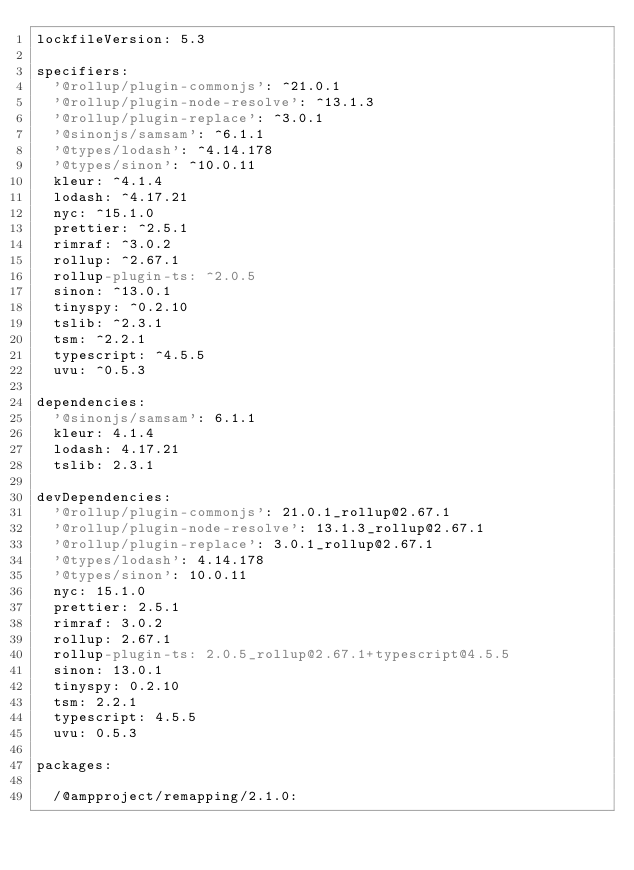<code> <loc_0><loc_0><loc_500><loc_500><_YAML_>lockfileVersion: 5.3

specifiers:
  '@rollup/plugin-commonjs': ^21.0.1
  '@rollup/plugin-node-resolve': ^13.1.3
  '@rollup/plugin-replace': ^3.0.1
  '@sinonjs/samsam': ^6.1.1
  '@types/lodash': ^4.14.178
  '@types/sinon': ^10.0.11
  kleur: ^4.1.4
  lodash: ^4.17.21
  nyc: ^15.1.0
  prettier: ^2.5.1
  rimraf: ^3.0.2
  rollup: ^2.67.1
  rollup-plugin-ts: ^2.0.5
  sinon: ^13.0.1
  tinyspy: ^0.2.10
  tslib: ^2.3.1
  tsm: ^2.2.1
  typescript: ^4.5.5
  uvu: ^0.5.3

dependencies:
  '@sinonjs/samsam': 6.1.1
  kleur: 4.1.4
  lodash: 4.17.21
  tslib: 2.3.1

devDependencies:
  '@rollup/plugin-commonjs': 21.0.1_rollup@2.67.1
  '@rollup/plugin-node-resolve': 13.1.3_rollup@2.67.1
  '@rollup/plugin-replace': 3.0.1_rollup@2.67.1
  '@types/lodash': 4.14.178
  '@types/sinon': 10.0.11
  nyc: 15.1.0
  prettier: 2.5.1
  rimraf: 3.0.2
  rollup: 2.67.1
  rollup-plugin-ts: 2.0.5_rollup@2.67.1+typescript@4.5.5
  sinon: 13.0.1
  tinyspy: 0.2.10
  tsm: 2.2.1
  typescript: 4.5.5
  uvu: 0.5.3

packages:

  /@ampproject/remapping/2.1.0:</code> 